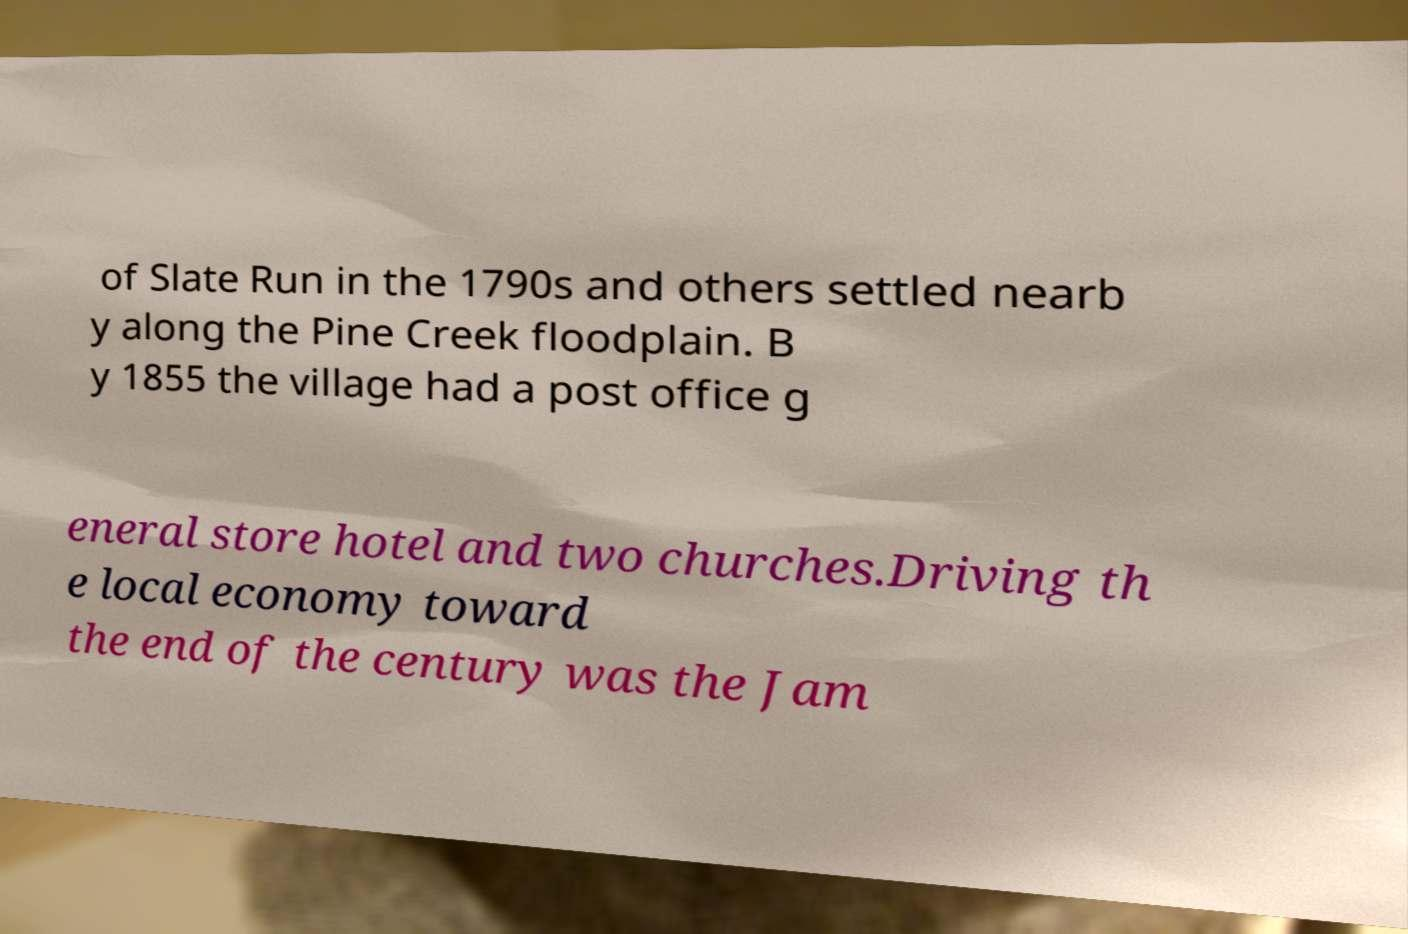Could you assist in decoding the text presented in this image and type it out clearly? of Slate Run in the 1790s and others settled nearb y along the Pine Creek floodplain. B y 1855 the village had a post office g eneral store hotel and two churches.Driving th e local economy toward the end of the century was the Jam 